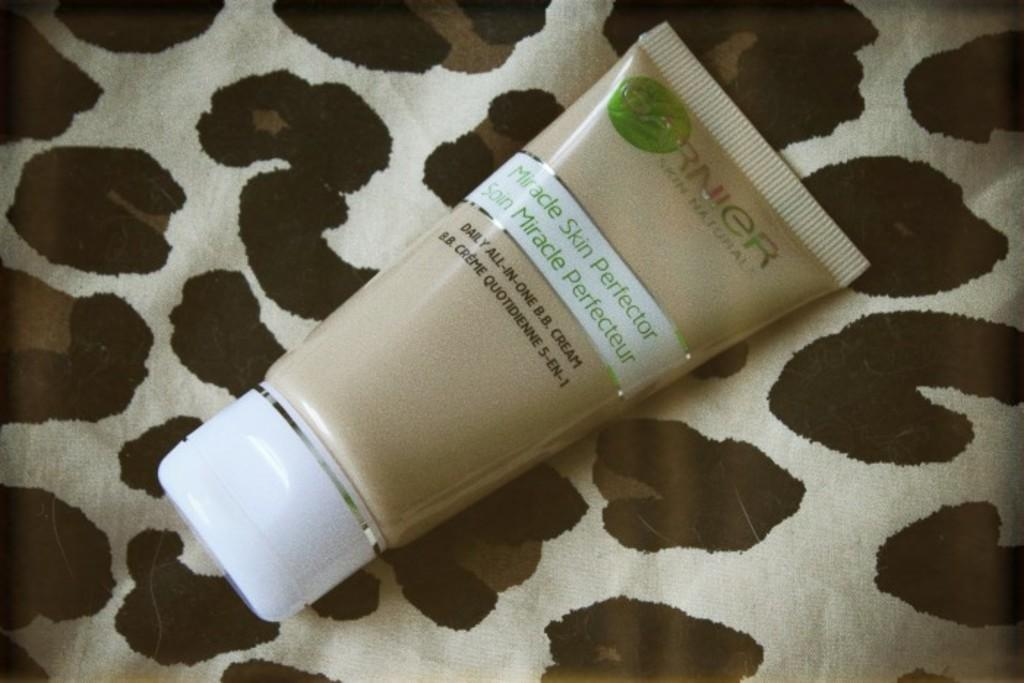<image>
Give a short and clear explanation of the subsequent image. A bottle of garnier miracle screen perfecter laying on a blanket. 